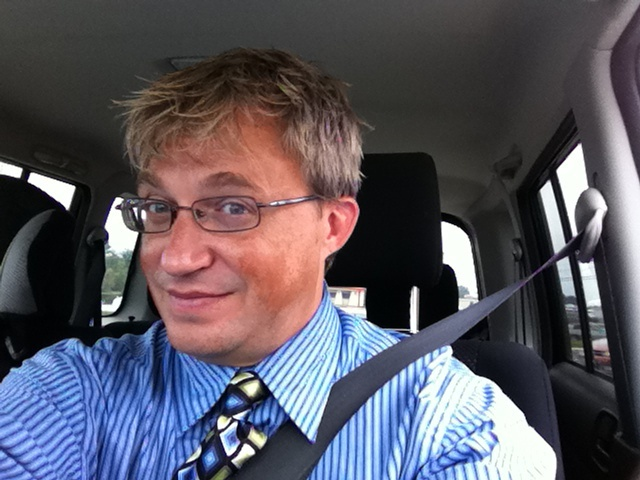Describe the objects in this image and their specific colors. I can see people in black, brown, white, and lightblue tones, tie in black, ivory, navy, and gray tones, and car in black and gray tones in this image. 